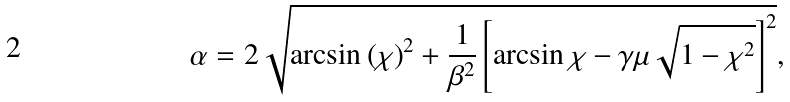<formula> <loc_0><loc_0><loc_500><loc_500>\alpha = 2 \sqrt { \arcsin \left ( \chi \right ) ^ { 2 } + \frac { 1 } { \beta ^ { 2 } } \left [ \arcsin \chi - \gamma \mu \sqrt { 1 - \chi ^ { 2 } } \right ] ^ { 2 } } ,</formula> 